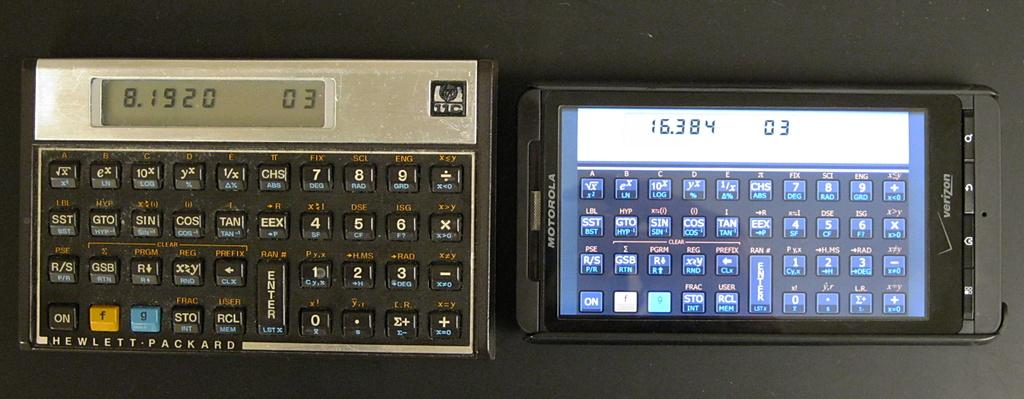<image>
Provide a brief description of the given image. an old fashioned keyboard with the number 03 displayed 